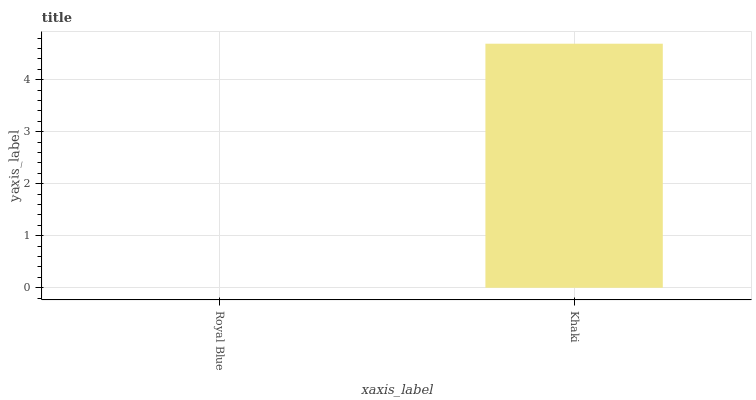Is Royal Blue the minimum?
Answer yes or no. Yes. Is Khaki the maximum?
Answer yes or no. Yes. Is Khaki the minimum?
Answer yes or no. No. Is Khaki greater than Royal Blue?
Answer yes or no. Yes. Is Royal Blue less than Khaki?
Answer yes or no. Yes. Is Royal Blue greater than Khaki?
Answer yes or no. No. Is Khaki less than Royal Blue?
Answer yes or no. No. Is Khaki the high median?
Answer yes or no. Yes. Is Royal Blue the low median?
Answer yes or no. Yes. Is Royal Blue the high median?
Answer yes or no. No. Is Khaki the low median?
Answer yes or no. No. 